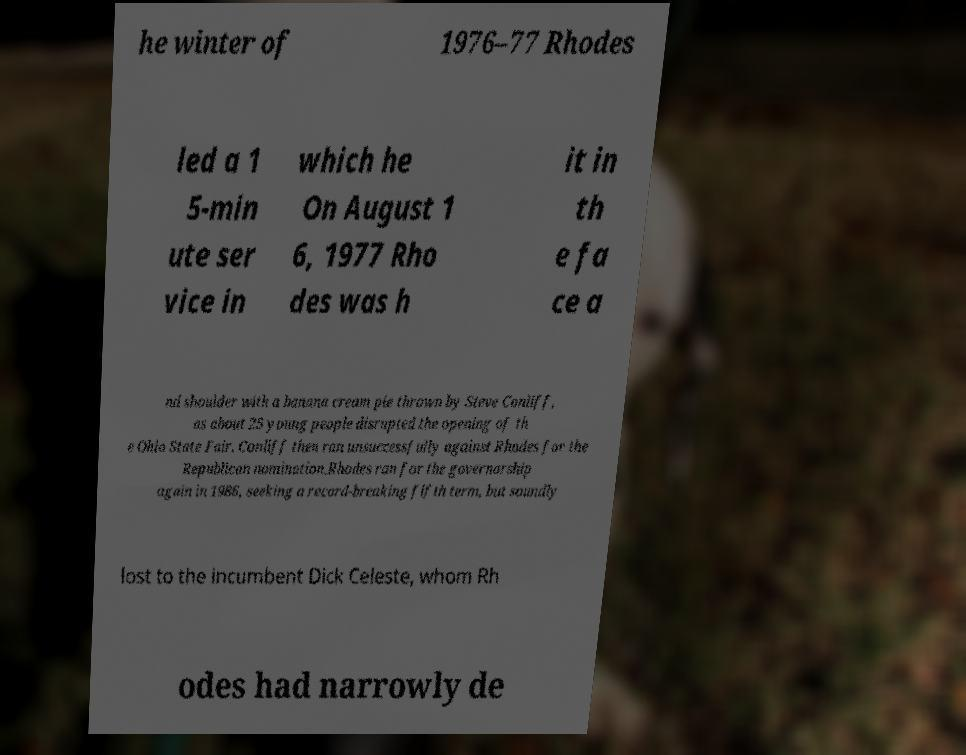Please identify and transcribe the text found in this image. he winter of 1976–77 Rhodes led a 1 5-min ute ser vice in which he On August 1 6, 1977 Rho des was h it in th e fa ce a nd shoulder with a banana cream pie thrown by Steve Conliff, as about 25 young people disrupted the opening of th e Ohio State Fair. Conliff then ran unsuccessfully against Rhodes for the Republican nomination.Rhodes ran for the governorship again in 1986, seeking a record-breaking fifth term, but soundly lost to the incumbent Dick Celeste, whom Rh odes had narrowly de 